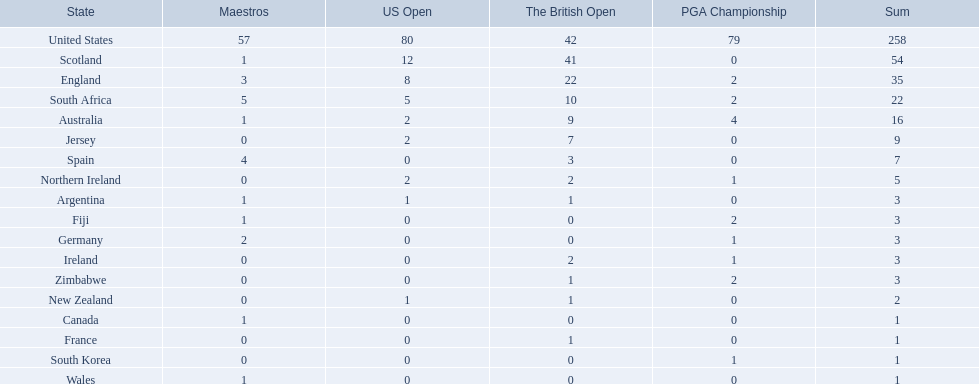Which of the countries listed are african? South Africa, Zimbabwe. Which of those has the least championship winning golfers? Zimbabwe. 